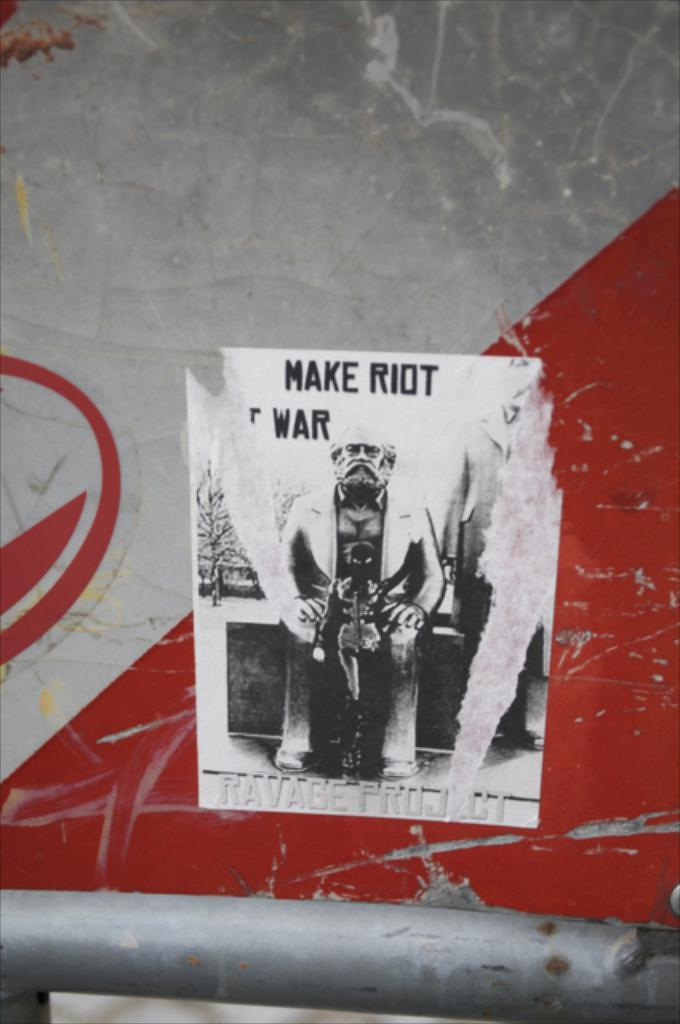What is located on the wall in the center of the image? There is a poster on the wall in the center of the image. What type of soup is being served in the heart-shaped bowl in the image? There is no soup or heart-shaped bowl present in the image; it only features a poster on the wall. 